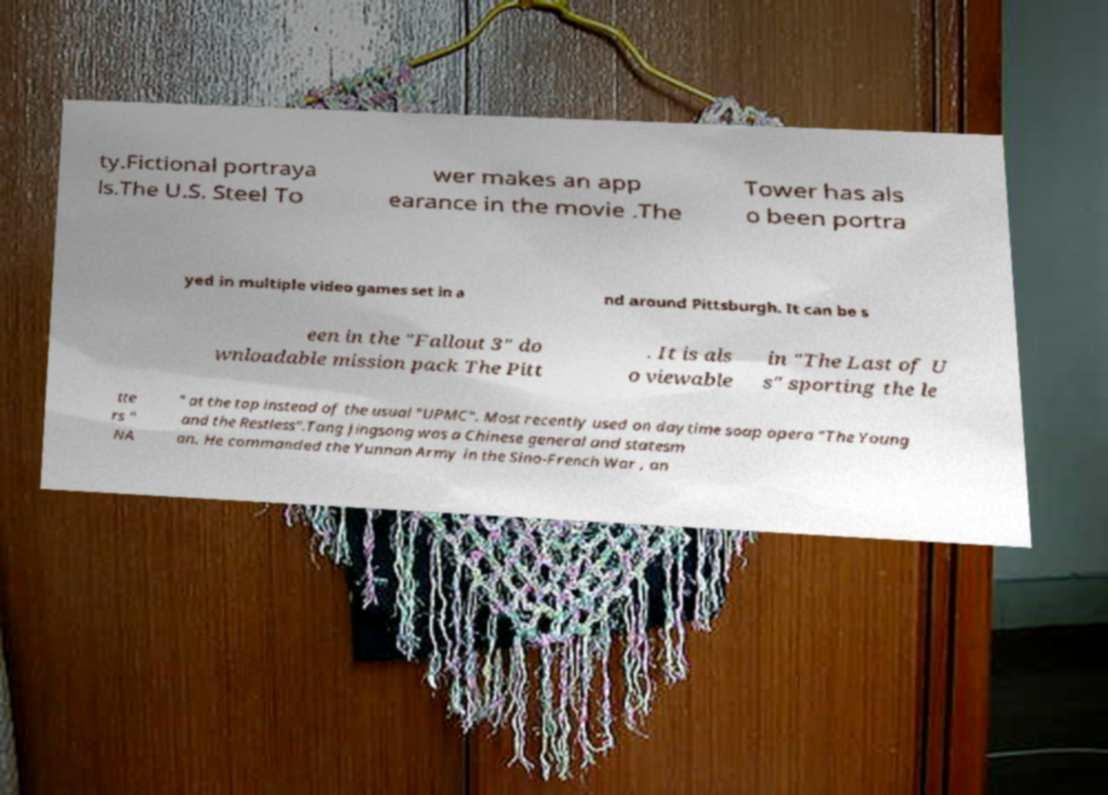What messages or text are displayed in this image? I need them in a readable, typed format. ty.Fictional portraya ls.The U.S. Steel To wer makes an app earance in the movie .The Tower has als o been portra yed in multiple video games set in a nd around Pittsburgh. It can be s een in the "Fallout 3" do wnloadable mission pack The Pitt . It is als o viewable in "The Last of U s" sporting the le tte rs " NA " at the top instead of the usual "UPMC". Most recently used on daytime soap opera "The Young and the Restless".Tang Jingsong was a Chinese general and statesm an. He commanded the Yunnan Army in the Sino-French War , an 